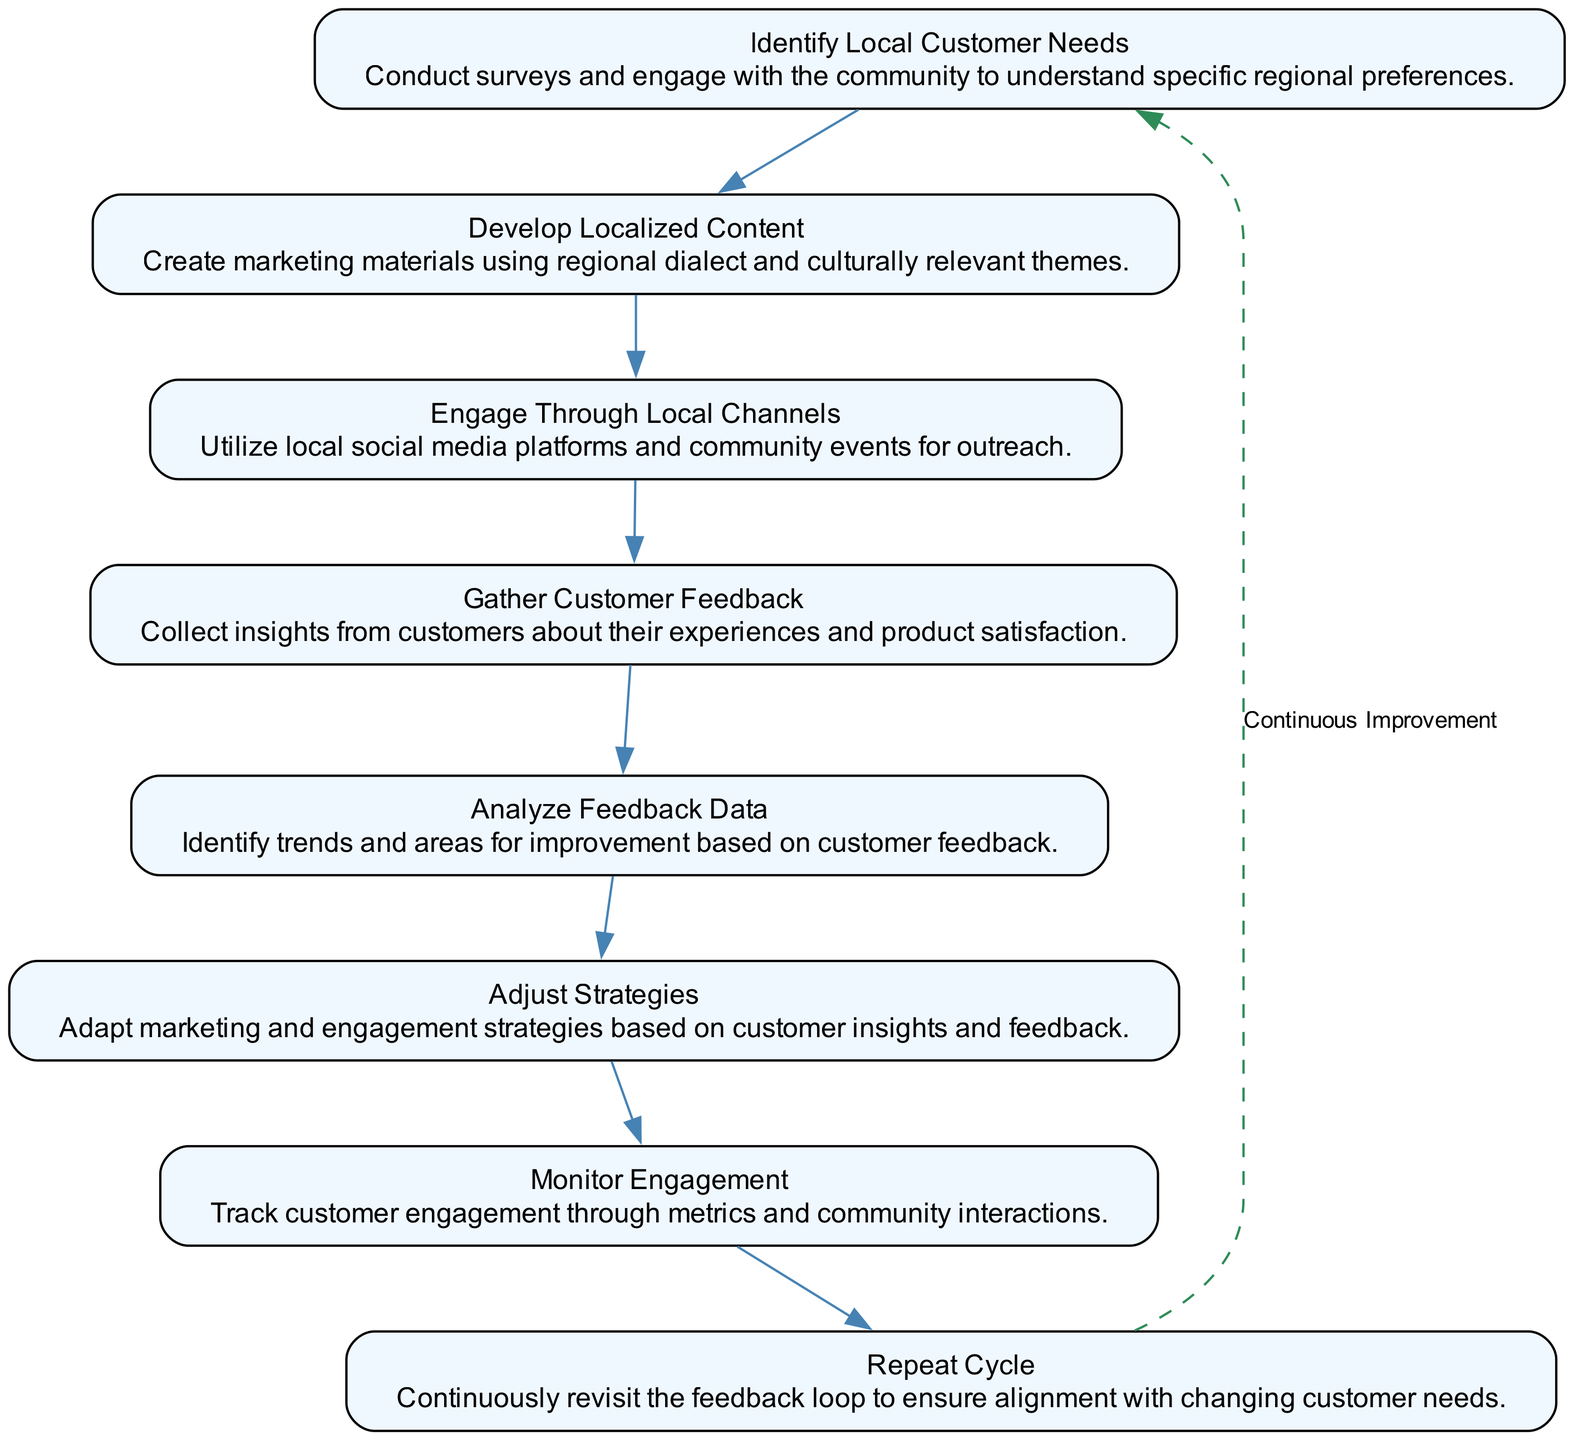What is the first step in the feedback loop? The first step in the feedback loop is "Identify Local Customer Needs," which involves conducting surveys and engaging with the community.
Answer: Identify Local Customer Needs How many nodes are present in the diagram? By counting the individual steps or phases in the process represented in the diagram, we can identify that there are a total of eight distinct nodes.
Answer: Eight What connects "Gather Customer Feedback" to "Analyze Feedback Data"? "Gather Customer Feedback" directly leads to "Analyze Feedback Data," representing the flow from collecting insights to analyzing them for trends.
Answer: Direct connection What is the purpose of "Engage Through Local Channels"? The purpose of "Engage Through Local Channels" is to utilize local social media platforms and community events for outreach, helping create a connection with customers.
Answer: Outreach Which step comes after "Adjust Strategies"? The step that follows "Adjust Strategies" in the feedback loop is "Monitor Engagement," indicating that after adjustments are made, it's important to track customer interactions.
Answer: Monitor Engagement How does feedback influence the overall loop? Feedback influences the overall loop by leading to the "Adjust Strategies" step, where strategies are adapted based on customer insights, thus emphasizing continuous improvement.
Answer: Continuous improvement What is the nature of the connection from "Monitor Engagement" to "Repeat Cycle"? The connection from "Monitor Engagement" to "Repeat Cycle" indicates that engagement tracking feeds back into the process to ensure strategies evolve with changing customer needs.
Answer: Feedback loop Which node includes customer satisfaction insights? The node that includes insights on customer satisfaction is "Gather Customer Feedback," where information on experiences and satisfaction is collected from customers.
Answer: Gather Customer Feedback 